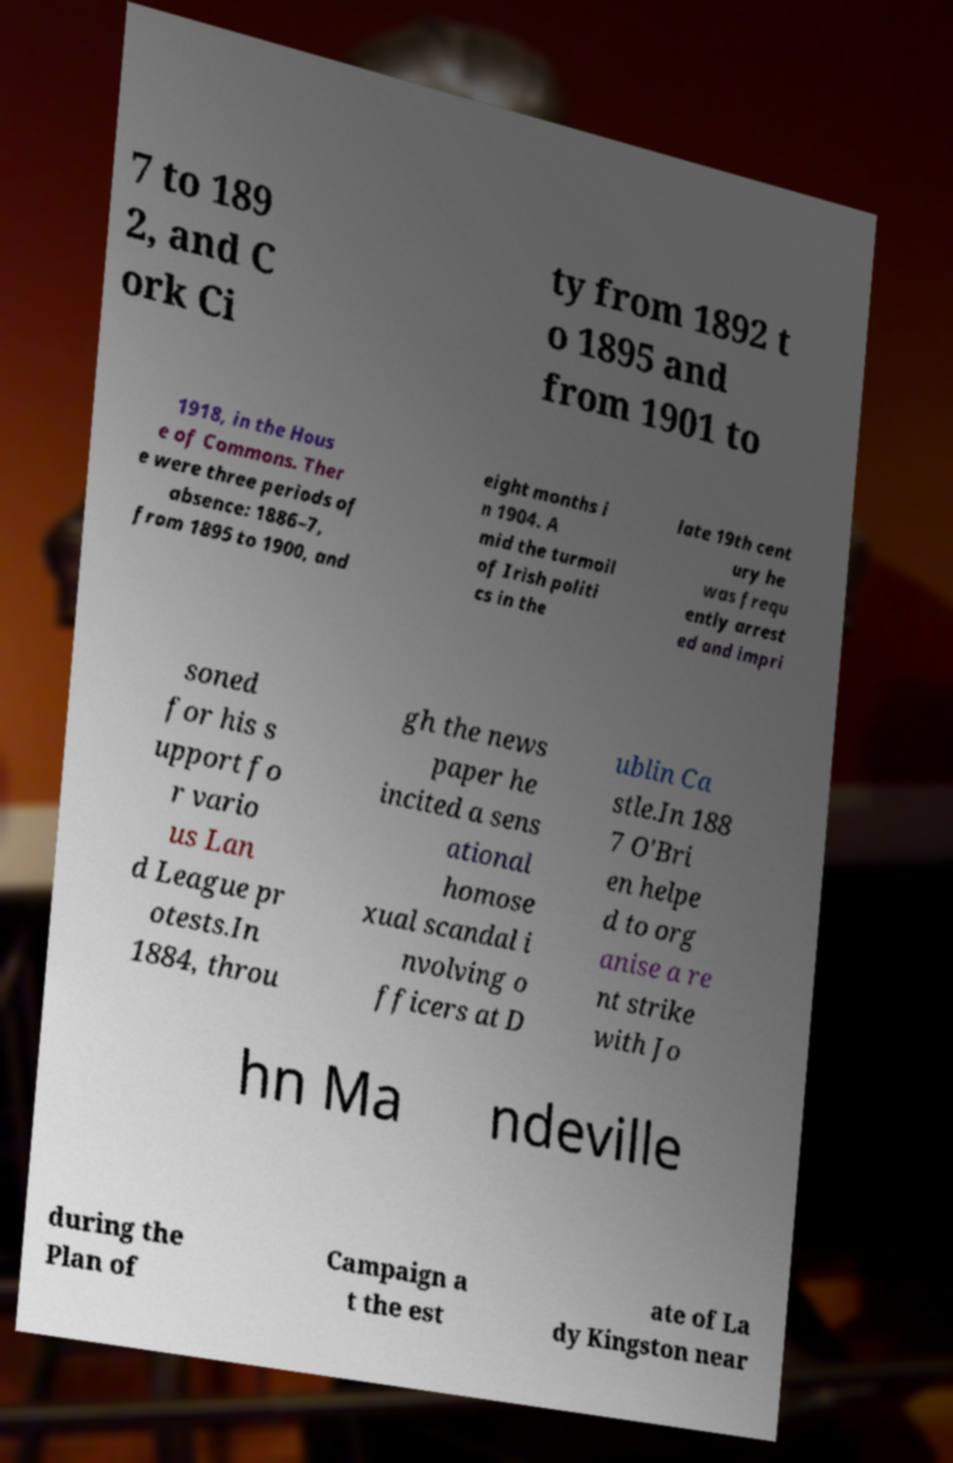I need the written content from this picture converted into text. Can you do that? 7 to 189 2, and C ork Ci ty from 1892 t o 1895 and from 1901 to 1918, in the Hous e of Commons. Ther e were three periods of absence: 1886–7, from 1895 to 1900, and eight months i n 1904. A mid the turmoil of Irish politi cs in the late 19th cent ury he was frequ ently arrest ed and impri soned for his s upport fo r vario us Lan d League pr otests.In 1884, throu gh the news paper he incited a sens ational homose xual scandal i nvolving o fficers at D ublin Ca stle.In 188 7 O'Bri en helpe d to org anise a re nt strike with Jo hn Ma ndeville during the Plan of Campaign a t the est ate of La dy Kingston near 